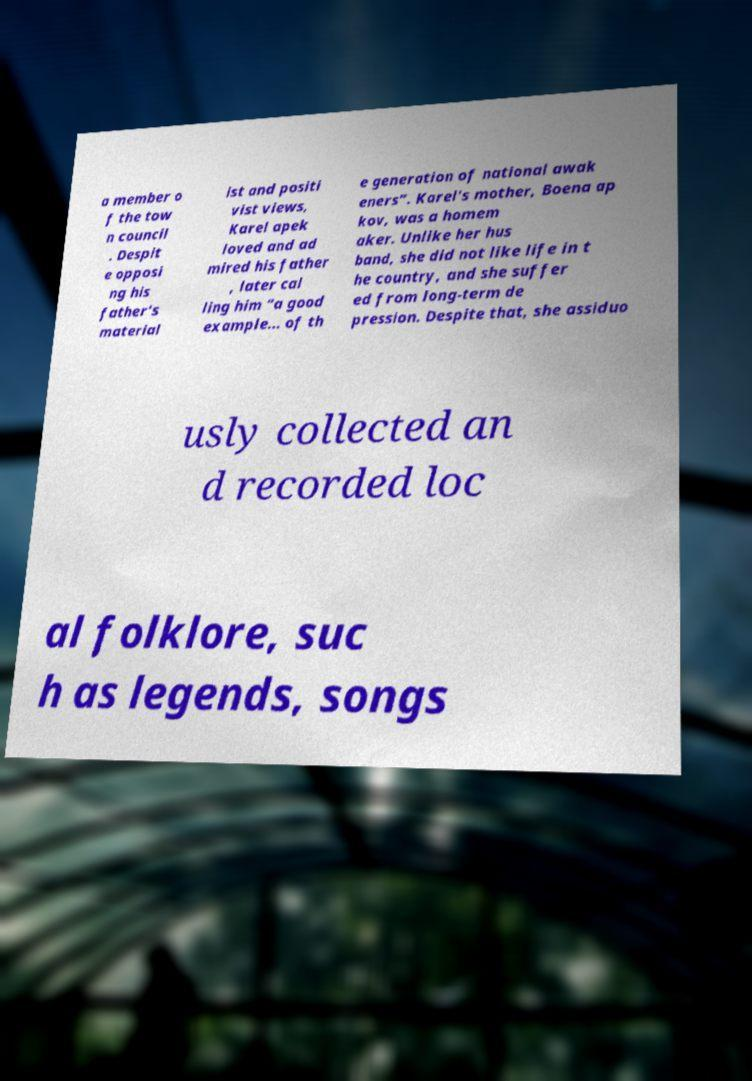For documentation purposes, I need the text within this image transcribed. Could you provide that? a member o f the tow n council . Despit e opposi ng his father's material ist and positi vist views, Karel apek loved and ad mired his father , later cal ling him “a good example... of th e generation of national awak eners”. Karel's mother, Boena ap kov, was a homem aker. Unlike her hus band, she did not like life in t he country, and she suffer ed from long-term de pression. Despite that, she assiduo usly collected an d recorded loc al folklore, suc h as legends, songs 